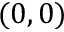<formula> <loc_0><loc_0><loc_500><loc_500>( 0 , 0 )</formula> 